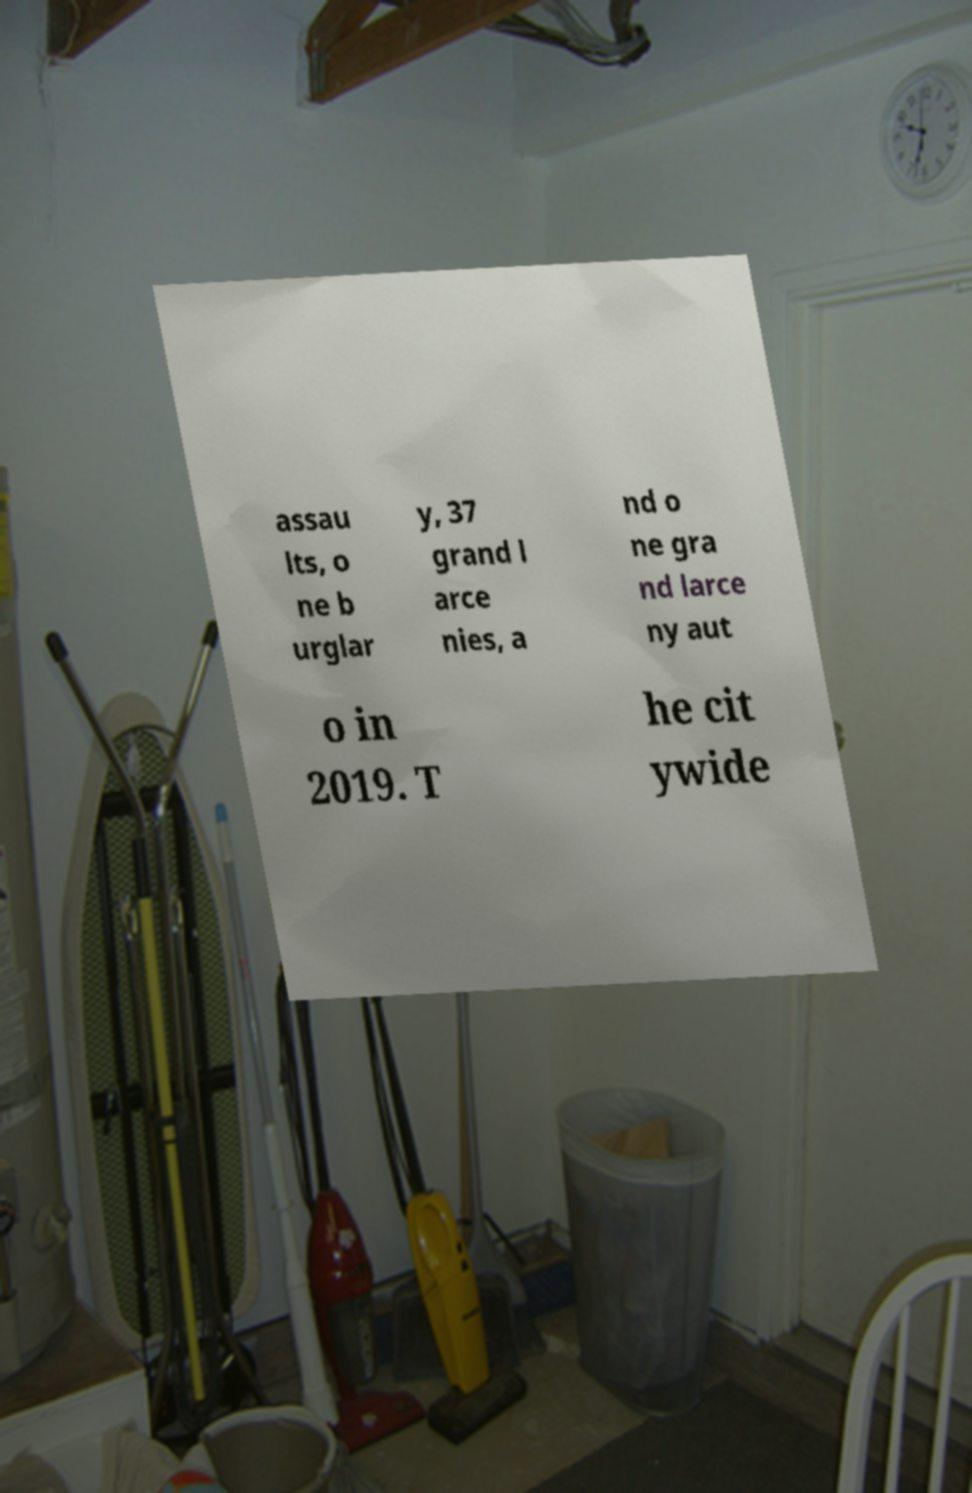For documentation purposes, I need the text within this image transcribed. Could you provide that? assau lts, o ne b urglar y, 37 grand l arce nies, a nd o ne gra nd larce ny aut o in 2019. T he cit ywide 